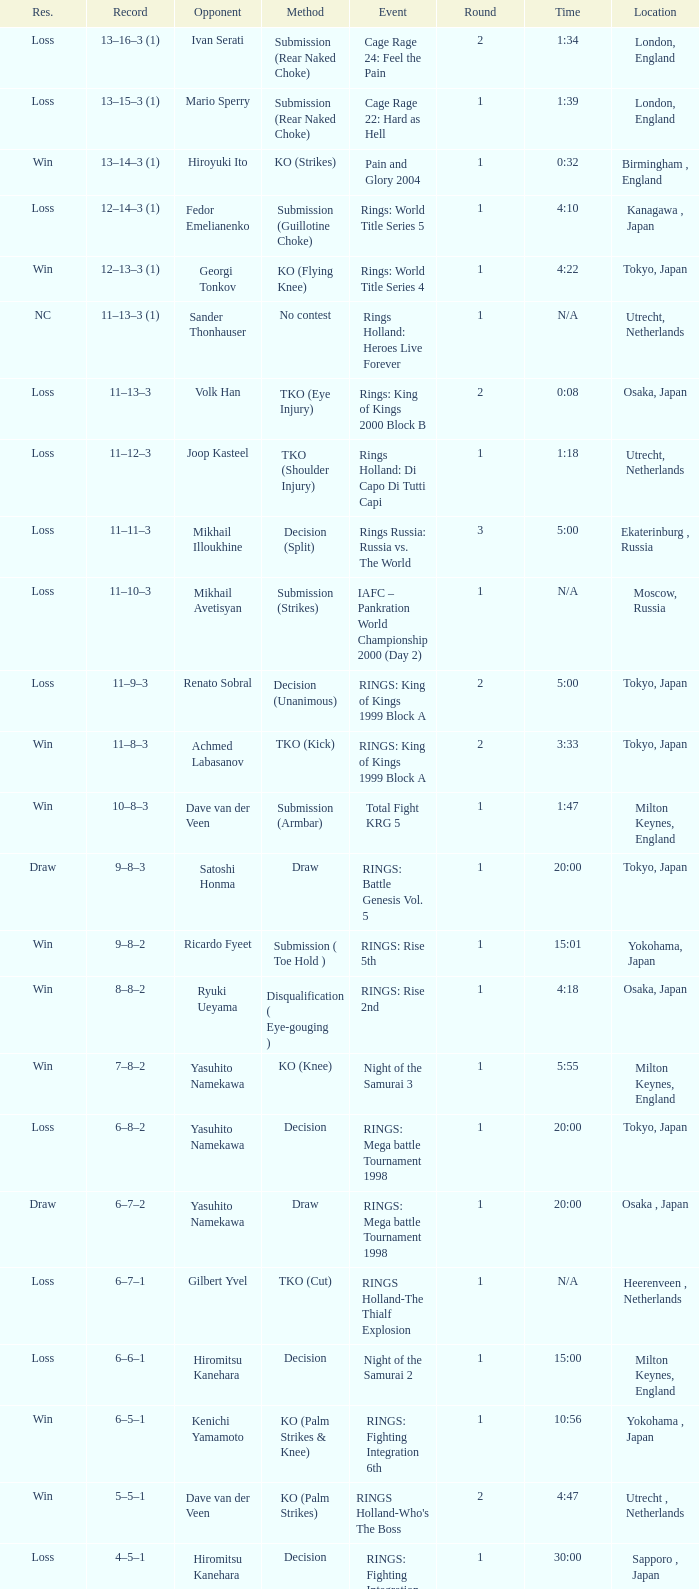Which occurrence involved an adversary of yasuhito namekawa with a determination technique? RINGS: Mega battle Tournament 1998. 